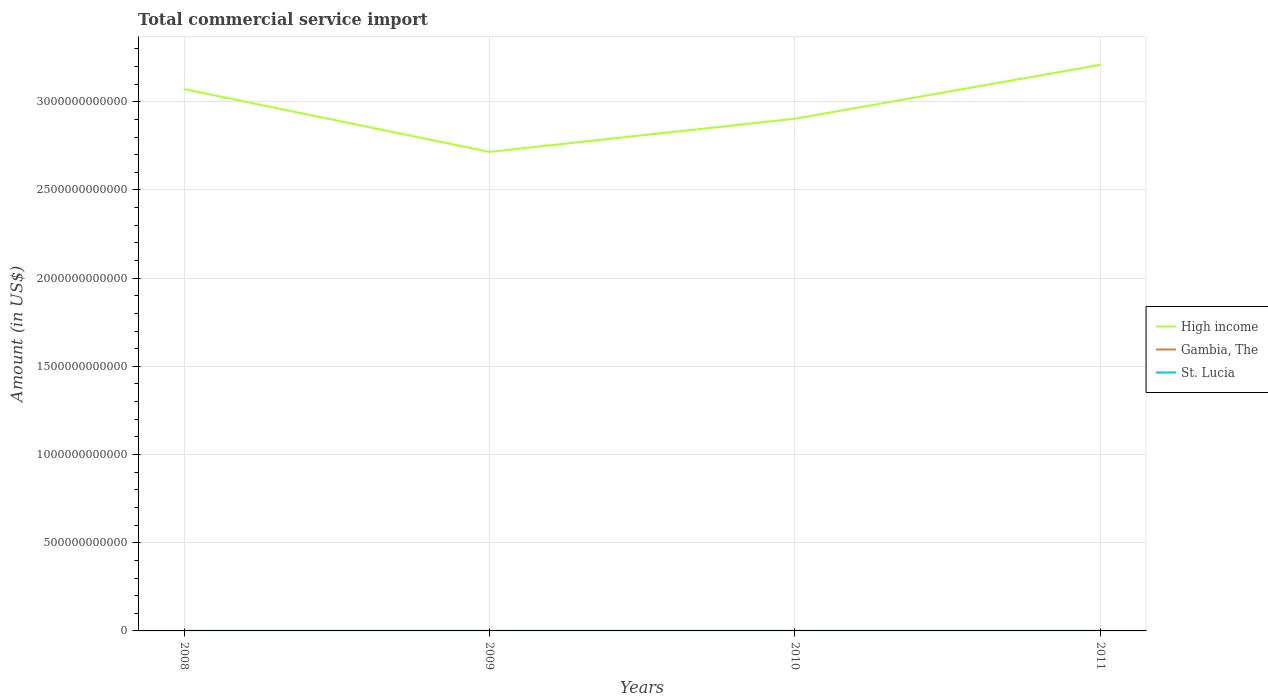Does the line corresponding to St. Lucia intersect with the line corresponding to High income?
Ensure brevity in your answer.  No. Is the number of lines equal to the number of legend labels?
Provide a succinct answer. Yes. Across all years, what is the maximum total commercial service import in High income?
Your response must be concise. 2.72e+12. In which year was the total commercial service import in High income maximum?
Your response must be concise. 2009. What is the total total commercial service import in High income in the graph?
Provide a succinct answer. 3.56e+11. What is the difference between the highest and the second highest total commercial service import in St. Lucia?
Your answer should be very brief. 2.41e+07. What is the difference between the highest and the lowest total commercial service import in Gambia, The?
Ensure brevity in your answer.  2. Is the total commercial service import in Gambia, The strictly greater than the total commercial service import in St. Lucia over the years?
Offer a terse response. Yes. What is the difference between two consecutive major ticks on the Y-axis?
Make the answer very short. 5.00e+11. Are the values on the major ticks of Y-axis written in scientific E-notation?
Your answer should be compact. No. Does the graph contain any zero values?
Ensure brevity in your answer.  No. Where does the legend appear in the graph?
Your response must be concise. Center right. What is the title of the graph?
Your answer should be very brief. Total commercial service import. What is the label or title of the Y-axis?
Offer a very short reply. Amount (in US$). What is the Amount (in US$) in High income in 2008?
Your answer should be very brief. 3.07e+12. What is the Amount (in US$) of Gambia, The in 2008?
Offer a terse response. 8.56e+07. What is the Amount (in US$) of St. Lucia in 2008?
Offer a very short reply. 2.09e+08. What is the Amount (in US$) of High income in 2009?
Keep it short and to the point. 2.72e+12. What is the Amount (in US$) in Gambia, The in 2009?
Provide a short and direct response. 8.26e+07. What is the Amount (in US$) in St. Lucia in 2009?
Keep it short and to the point. 1.85e+08. What is the Amount (in US$) in High income in 2010?
Your response must be concise. 2.90e+12. What is the Amount (in US$) of Gambia, The in 2010?
Provide a short and direct response. 7.32e+07. What is the Amount (in US$) in St. Lucia in 2010?
Give a very brief answer. 2.00e+08. What is the Amount (in US$) of High income in 2011?
Offer a terse response. 3.21e+12. What is the Amount (in US$) of Gambia, The in 2011?
Provide a short and direct response. 6.84e+07. What is the Amount (in US$) in St. Lucia in 2011?
Ensure brevity in your answer.  1.97e+08. Across all years, what is the maximum Amount (in US$) of High income?
Keep it short and to the point. 3.21e+12. Across all years, what is the maximum Amount (in US$) of Gambia, The?
Provide a short and direct response. 8.56e+07. Across all years, what is the maximum Amount (in US$) in St. Lucia?
Provide a short and direct response. 2.09e+08. Across all years, what is the minimum Amount (in US$) in High income?
Your answer should be compact. 2.72e+12. Across all years, what is the minimum Amount (in US$) in Gambia, The?
Keep it short and to the point. 6.84e+07. Across all years, what is the minimum Amount (in US$) of St. Lucia?
Give a very brief answer. 1.85e+08. What is the total Amount (in US$) of High income in the graph?
Offer a terse response. 1.19e+13. What is the total Amount (in US$) in Gambia, The in the graph?
Your response must be concise. 3.10e+08. What is the total Amount (in US$) of St. Lucia in the graph?
Offer a terse response. 7.91e+08. What is the difference between the Amount (in US$) of High income in 2008 and that in 2009?
Keep it short and to the point. 3.56e+11. What is the difference between the Amount (in US$) of Gambia, The in 2008 and that in 2009?
Make the answer very short. 3.08e+06. What is the difference between the Amount (in US$) in St. Lucia in 2008 and that in 2009?
Your response must be concise. 2.41e+07. What is the difference between the Amount (in US$) of High income in 2008 and that in 2010?
Your response must be concise. 1.68e+11. What is the difference between the Amount (in US$) of Gambia, The in 2008 and that in 2010?
Provide a succinct answer. 1.25e+07. What is the difference between the Amount (in US$) in St. Lucia in 2008 and that in 2010?
Your answer should be very brief. 9.05e+06. What is the difference between the Amount (in US$) in High income in 2008 and that in 2011?
Offer a very short reply. -1.38e+11. What is the difference between the Amount (in US$) of Gambia, The in 2008 and that in 2011?
Your answer should be very brief. 1.72e+07. What is the difference between the Amount (in US$) in St. Lucia in 2008 and that in 2011?
Ensure brevity in your answer.  1.15e+07. What is the difference between the Amount (in US$) of High income in 2009 and that in 2010?
Your answer should be compact. -1.88e+11. What is the difference between the Amount (in US$) of Gambia, The in 2009 and that in 2010?
Ensure brevity in your answer.  9.39e+06. What is the difference between the Amount (in US$) of St. Lucia in 2009 and that in 2010?
Your answer should be compact. -1.51e+07. What is the difference between the Amount (in US$) of High income in 2009 and that in 2011?
Offer a terse response. -4.93e+11. What is the difference between the Amount (in US$) of Gambia, The in 2009 and that in 2011?
Your response must be concise. 1.42e+07. What is the difference between the Amount (in US$) of St. Lucia in 2009 and that in 2011?
Make the answer very short. -1.26e+07. What is the difference between the Amount (in US$) of High income in 2010 and that in 2011?
Your response must be concise. -3.06e+11. What is the difference between the Amount (in US$) in Gambia, The in 2010 and that in 2011?
Keep it short and to the point. 4.77e+06. What is the difference between the Amount (in US$) in St. Lucia in 2010 and that in 2011?
Ensure brevity in your answer.  2.48e+06. What is the difference between the Amount (in US$) of High income in 2008 and the Amount (in US$) of Gambia, The in 2009?
Give a very brief answer. 3.07e+12. What is the difference between the Amount (in US$) in High income in 2008 and the Amount (in US$) in St. Lucia in 2009?
Keep it short and to the point. 3.07e+12. What is the difference between the Amount (in US$) in Gambia, The in 2008 and the Amount (in US$) in St. Lucia in 2009?
Ensure brevity in your answer.  -9.91e+07. What is the difference between the Amount (in US$) in High income in 2008 and the Amount (in US$) in Gambia, The in 2010?
Your answer should be very brief. 3.07e+12. What is the difference between the Amount (in US$) in High income in 2008 and the Amount (in US$) in St. Lucia in 2010?
Provide a short and direct response. 3.07e+12. What is the difference between the Amount (in US$) of Gambia, The in 2008 and the Amount (in US$) of St. Lucia in 2010?
Make the answer very short. -1.14e+08. What is the difference between the Amount (in US$) of High income in 2008 and the Amount (in US$) of Gambia, The in 2011?
Provide a short and direct response. 3.07e+12. What is the difference between the Amount (in US$) of High income in 2008 and the Amount (in US$) of St. Lucia in 2011?
Ensure brevity in your answer.  3.07e+12. What is the difference between the Amount (in US$) in Gambia, The in 2008 and the Amount (in US$) in St. Lucia in 2011?
Your answer should be compact. -1.12e+08. What is the difference between the Amount (in US$) in High income in 2009 and the Amount (in US$) in Gambia, The in 2010?
Your response must be concise. 2.72e+12. What is the difference between the Amount (in US$) in High income in 2009 and the Amount (in US$) in St. Lucia in 2010?
Provide a short and direct response. 2.72e+12. What is the difference between the Amount (in US$) in Gambia, The in 2009 and the Amount (in US$) in St. Lucia in 2010?
Make the answer very short. -1.17e+08. What is the difference between the Amount (in US$) in High income in 2009 and the Amount (in US$) in Gambia, The in 2011?
Offer a very short reply. 2.72e+12. What is the difference between the Amount (in US$) of High income in 2009 and the Amount (in US$) of St. Lucia in 2011?
Provide a succinct answer. 2.72e+12. What is the difference between the Amount (in US$) in Gambia, The in 2009 and the Amount (in US$) in St. Lucia in 2011?
Your answer should be compact. -1.15e+08. What is the difference between the Amount (in US$) of High income in 2010 and the Amount (in US$) of Gambia, The in 2011?
Provide a succinct answer. 2.90e+12. What is the difference between the Amount (in US$) of High income in 2010 and the Amount (in US$) of St. Lucia in 2011?
Offer a terse response. 2.90e+12. What is the difference between the Amount (in US$) of Gambia, The in 2010 and the Amount (in US$) of St. Lucia in 2011?
Make the answer very short. -1.24e+08. What is the average Amount (in US$) in High income per year?
Keep it short and to the point. 2.98e+12. What is the average Amount (in US$) of Gambia, The per year?
Make the answer very short. 7.74e+07. What is the average Amount (in US$) of St. Lucia per year?
Ensure brevity in your answer.  1.98e+08. In the year 2008, what is the difference between the Amount (in US$) of High income and Amount (in US$) of Gambia, The?
Your answer should be compact. 3.07e+12. In the year 2008, what is the difference between the Amount (in US$) of High income and Amount (in US$) of St. Lucia?
Your answer should be compact. 3.07e+12. In the year 2008, what is the difference between the Amount (in US$) in Gambia, The and Amount (in US$) in St. Lucia?
Make the answer very short. -1.23e+08. In the year 2009, what is the difference between the Amount (in US$) of High income and Amount (in US$) of Gambia, The?
Offer a very short reply. 2.72e+12. In the year 2009, what is the difference between the Amount (in US$) of High income and Amount (in US$) of St. Lucia?
Make the answer very short. 2.72e+12. In the year 2009, what is the difference between the Amount (in US$) in Gambia, The and Amount (in US$) in St. Lucia?
Provide a short and direct response. -1.02e+08. In the year 2010, what is the difference between the Amount (in US$) of High income and Amount (in US$) of Gambia, The?
Keep it short and to the point. 2.90e+12. In the year 2010, what is the difference between the Amount (in US$) in High income and Amount (in US$) in St. Lucia?
Your response must be concise. 2.90e+12. In the year 2010, what is the difference between the Amount (in US$) in Gambia, The and Amount (in US$) in St. Lucia?
Your response must be concise. -1.27e+08. In the year 2011, what is the difference between the Amount (in US$) of High income and Amount (in US$) of Gambia, The?
Offer a terse response. 3.21e+12. In the year 2011, what is the difference between the Amount (in US$) in High income and Amount (in US$) in St. Lucia?
Provide a short and direct response. 3.21e+12. In the year 2011, what is the difference between the Amount (in US$) of Gambia, The and Amount (in US$) of St. Lucia?
Your response must be concise. -1.29e+08. What is the ratio of the Amount (in US$) in High income in 2008 to that in 2009?
Give a very brief answer. 1.13. What is the ratio of the Amount (in US$) of Gambia, The in 2008 to that in 2009?
Provide a short and direct response. 1.04. What is the ratio of the Amount (in US$) in St. Lucia in 2008 to that in 2009?
Keep it short and to the point. 1.13. What is the ratio of the Amount (in US$) of High income in 2008 to that in 2010?
Ensure brevity in your answer.  1.06. What is the ratio of the Amount (in US$) in Gambia, The in 2008 to that in 2010?
Your answer should be very brief. 1.17. What is the ratio of the Amount (in US$) of St. Lucia in 2008 to that in 2010?
Offer a terse response. 1.05. What is the ratio of the Amount (in US$) of High income in 2008 to that in 2011?
Ensure brevity in your answer.  0.96. What is the ratio of the Amount (in US$) in Gambia, The in 2008 to that in 2011?
Make the answer very short. 1.25. What is the ratio of the Amount (in US$) of St. Lucia in 2008 to that in 2011?
Ensure brevity in your answer.  1.06. What is the ratio of the Amount (in US$) of High income in 2009 to that in 2010?
Provide a short and direct response. 0.94. What is the ratio of the Amount (in US$) of Gambia, The in 2009 to that in 2010?
Your answer should be very brief. 1.13. What is the ratio of the Amount (in US$) in St. Lucia in 2009 to that in 2010?
Make the answer very short. 0.92. What is the ratio of the Amount (in US$) of High income in 2009 to that in 2011?
Ensure brevity in your answer.  0.85. What is the ratio of the Amount (in US$) of Gambia, The in 2009 to that in 2011?
Your response must be concise. 1.21. What is the ratio of the Amount (in US$) in St. Lucia in 2009 to that in 2011?
Provide a short and direct response. 0.94. What is the ratio of the Amount (in US$) in High income in 2010 to that in 2011?
Your response must be concise. 0.9. What is the ratio of the Amount (in US$) of Gambia, The in 2010 to that in 2011?
Ensure brevity in your answer.  1.07. What is the ratio of the Amount (in US$) in St. Lucia in 2010 to that in 2011?
Your answer should be very brief. 1.01. What is the difference between the highest and the second highest Amount (in US$) in High income?
Ensure brevity in your answer.  1.38e+11. What is the difference between the highest and the second highest Amount (in US$) of Gambia, The?
Give a very brief answer. 3.08e+06. What is the difference between the highest and the second highest Amount (in US$) in St. Lucia?
Your answer should be compact. 9.05e+06. What is the difference between the highest and the lowest Amount (in US$) of High income?
Make the answer very short. 4.93e+11. What is the difference between the highest and the lowest Amount (in US$) in Gambia, The?
Your response must be concise. 1.72e+07. What is the difference between the highest and the lowest Amount (in US$) in St. Lucia?
Make the answer very short. 2.41e+07. 